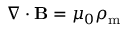<formula> <loc_0><loc_0><loc_500><loc_500>\nabla \cdot B = \mu _ { 0 } \rho _ { m }</formula> 